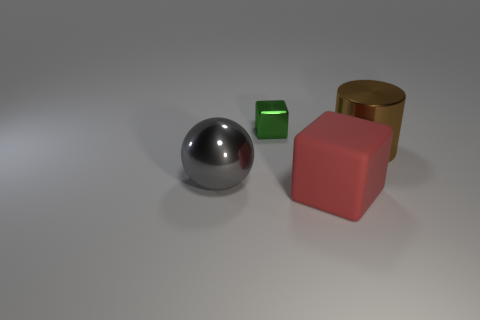What is the material of the red block?
Your answer should be very brief. Rubber. There is a object behind the brown object; is it the same shape as the large red thing?
Keep it short and to the point. Yes. Is there a thing of the same size as the cylinder?
Your answer should be very brief. Yes. There is a metallic thing in front of the large object right of the big cube; are there any big metal cylinders right of it?
Offer a very short reply. Yes. What material is the big cylinder in front of the tiny green cube that is behind the shiny object that is right of the rubber object made of?
Provide a succinct answer. Metal. What shape is the big metallic thing that is left of the small green object?
Ensure brevity in your answer.  Sphere. What size is the green cube that is the same material as the big cylinder?
Ensure brevity in your answer.  Small. What number of other small objects have the same shape as the tiny metallic thing?
Make the answer very short. 0. There is a big metal thing that is behind the big shiny thing on the left side of the large red thing; how many large metal objects are in front of it?
Give a very brief answer. 1. What number of big objects are on the right side of the tiny metal thing and in front of the large brown thing?
Ensure brevity in your answer.  1. 